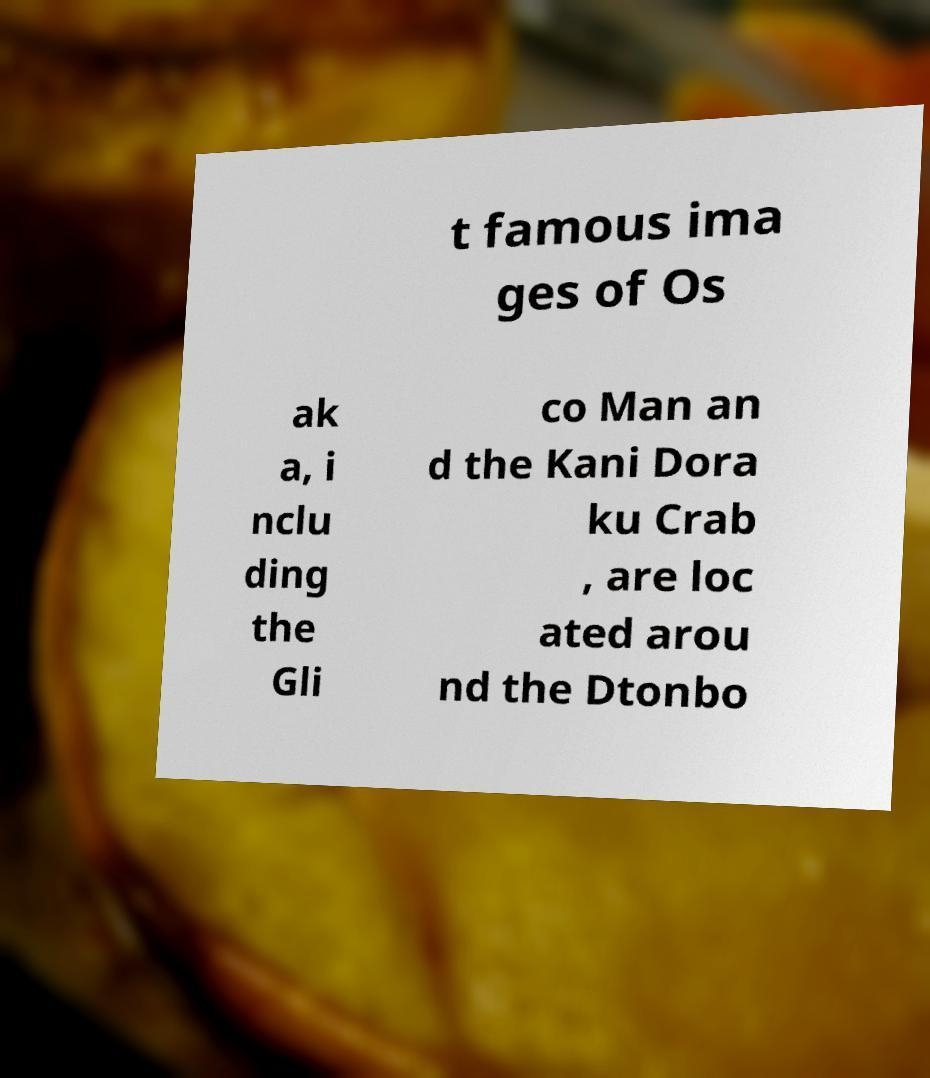Could you assist in decoding the text presented in this image and type it out clearly? t famous ima ges of Os ak a, i nclu ding the Gli co Man an d the Kani Dora ku Crab , are loc ated arou nd the Dtonbo 